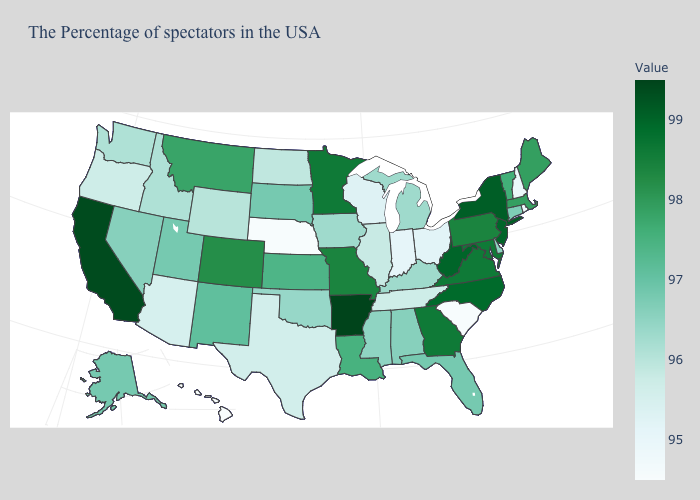Which states have the lowest value in the USA?
Write a very short answer. South Carolina, Nebraska, Hawaii. Is the legend a continuous bar?
Answer briefly. Yes. Among the states that border Arizona , which have the lowest value?
Answer briefly. Nevada. Does Arkansas have the highest value in the USA?
Give a very brief answer. Yes. Among the states that border Idaho , does Wyoming have the highest value?
Short answer required. No. Is the legend a continuous bar?
Write a very short answer. Yes. 